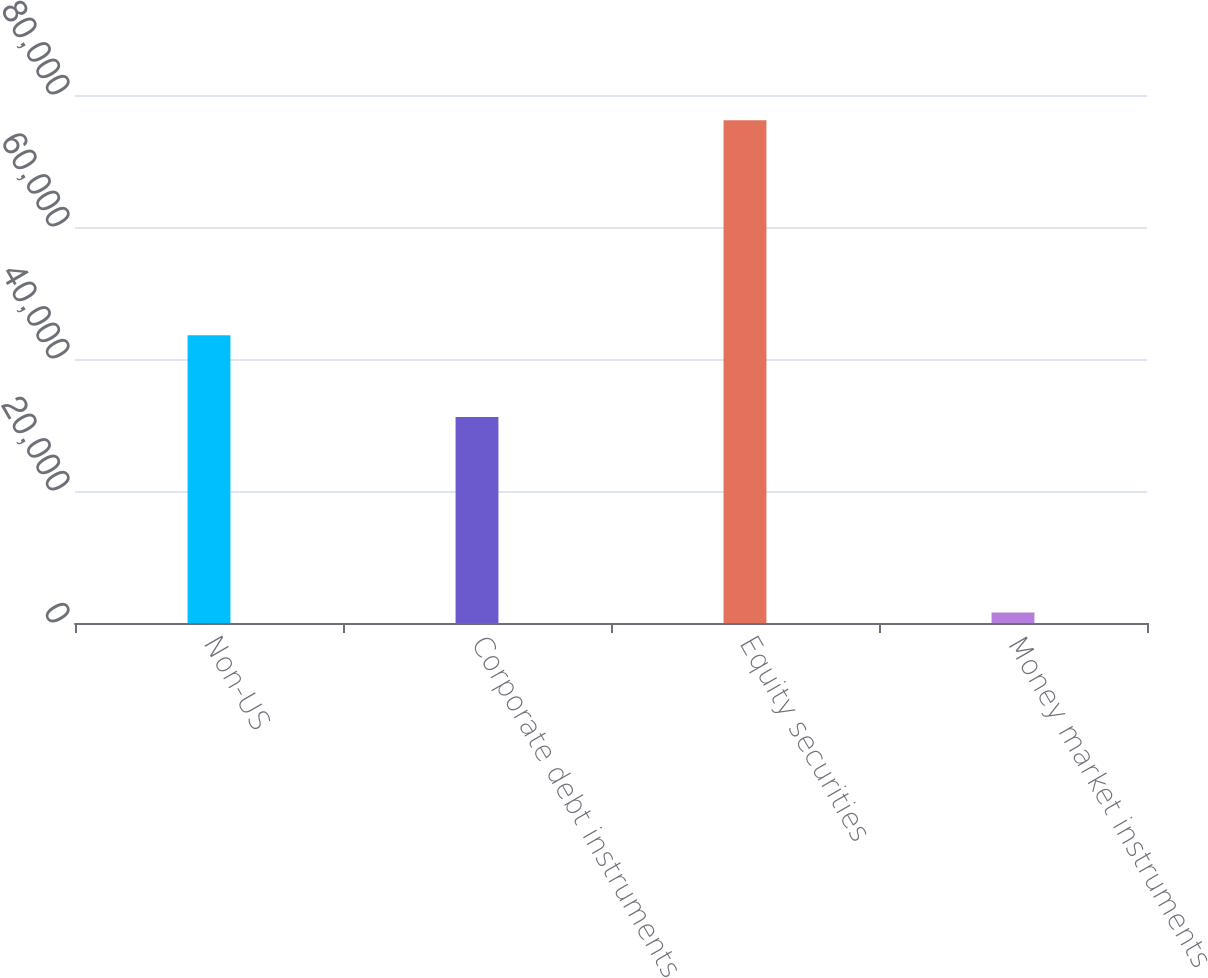Convert chart. <chart><loc_0><loc_0><loc_500><loc_500><bar_chart><fcel>Non-US<fcel>Corporate debt instruments<fcel>Equity securities<fcel>Money market instruments<nl><fcel>43607<fcel>31207<fcel>76170<fcel>1608<nl></chart> 